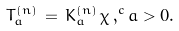Convert formula to latex. <formula><loc_0><loc_0><loc_500><loc_500>T _ { a } ^ { ( n ) } \, = \, K _ { a } ^ { ( n ) } \, \chi \, , ^ { c } a > 0 .</formula> 